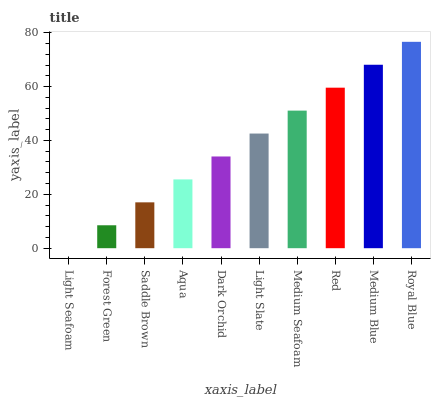Is Light Seafoam the minimum?
Answer yes or no. Yes. Is Royal Blue the maximum?
Answer yes or no. Yes. Is Forest Green the minimum?
Answer yes or no. No. Is Forest Green the maximum?
Answer yes or no. No. Is Forest Green greater than Light Seafoam?
Answer yes or no. Yes. Is Light Seafoam less than Forest Green?
Answer yes or no. Yes. Is Light Seafoam greater than Forest Green?
Answer yes or no. No. Is Forest Green less than Light Seafoam?
Answer yes or no. No. Is Light Slate the high median?
Answer yes or no. Yes. Is Dark Orchid the low median?
Answer yes or no. Yes. Is Light Seafoam the high median?
Answer yes or no. No. Is Red the low median?
Answer yes or no. No. 